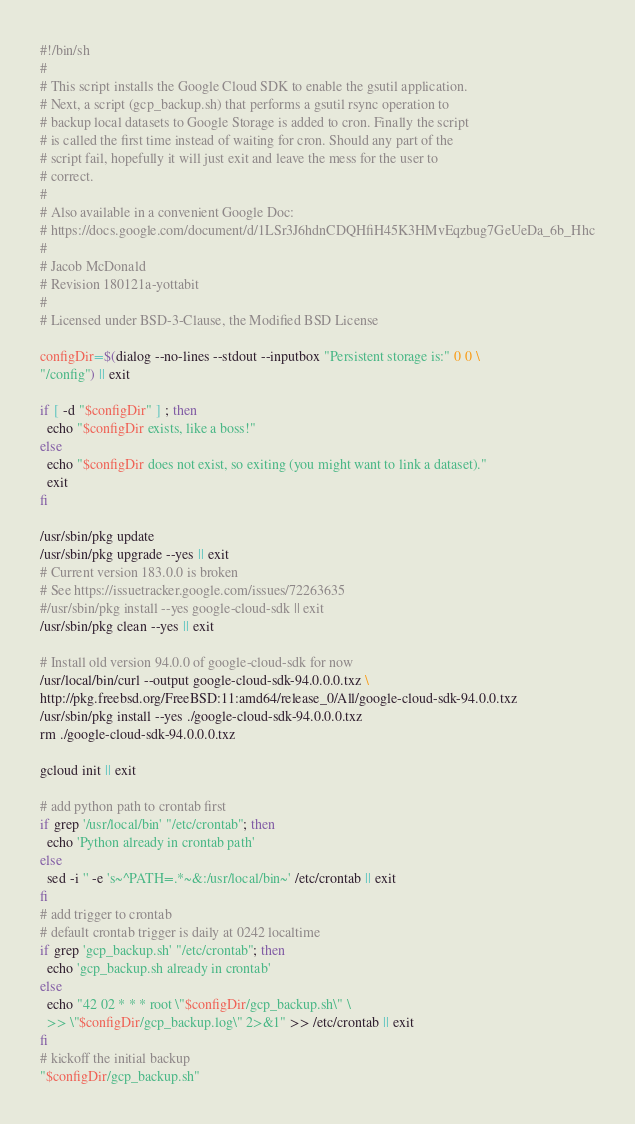<code> <loc_0><loc_0><loc_500><loc_500><_Bash_>#!/bin/sh
#
# This script installs the Google Cloud SDK to enable the gsutil application. 
# Next, a script (gcp_backup.sh) that performs a gsutil rsync operation to
# backup local datasets to Google Storage is added to cron. Finally the script
# is called the first time instead of waiting for cron. Should any part of the
# script fail, hopefully it will just exit and leave the mess for the user to
# correct.
#
# Also available in a convenient Google Doc:
# https://docs.google.com/document/d/1LSr3J6hdnCDQHfiH45K3HMvEqzbug7GeUeDa_6b_Hhc
#
# Jacob McDonald
# Revision 180121a-yottabit
#
# Licensed under BSD-3-Clause, the Modified BSD License

configDir=$(dialog --no-lines --stdout --inputbox "Persistent storage is:" 0 0 \
"/config") || exit

if [ -d "$configDir" ] ; then
  echo "$configDir exists, like a boss!"
else
  echo "$configDir does not exist, so exiting (you might want to link a dataset)."
  exit
fi

/usr/sbin/pkg update
/usr/sbin/pkg upgrade --yes || exit
# Current version 183.0.0 is broken
# See https://issuetracker.google.com/issues/72263635
#/usr/sbin/pkg install --yes google-cloud-sdk || exit
/usr/sbin/pkg clean --yes || exit

# Install old version 94.0.0 of google-cloud-sdk for now
/usr/local/bin/curl --output google-cloud-sdk-94.0.0.0.txz \
http://pkg.freebsd.org/FreeBSD:11:amd64/release_0/All/google-cloud-sdk-94.0.0.txz
/usr/sbin/pkg install --yes ./google-cloud-sdk-94.0.0.0.txz
rm ./google-cloud-sdk-94.0.0.0.txz

gcloud init || exit

# add python path to crontab first
if grep '/usr/local/bin' "/etc/crontab"; then
  echo 'Python already in crontab path'
else
  sed -i '' -e 's~^PATH=.*~&:/usr/local/bin~' /etc/crontab || exit
fi
# add trigger to crontab
# default crontab trigger is daily at 0242 localtime
if grep 'gcp_backup.sh' "/etc/crontab"; then
  echo 'gcp_backup.sh already in crontab'
else
  echo "42 02 * * * root \"$configDir/gcp_backup.sh\" \
  >> \"$configDir/gcp_backup.log\" 2>&1" >> /etc/crontab || exit
fi
# kickoff the initial backup
"$configDir/gcp_backup.sh"
</code> 